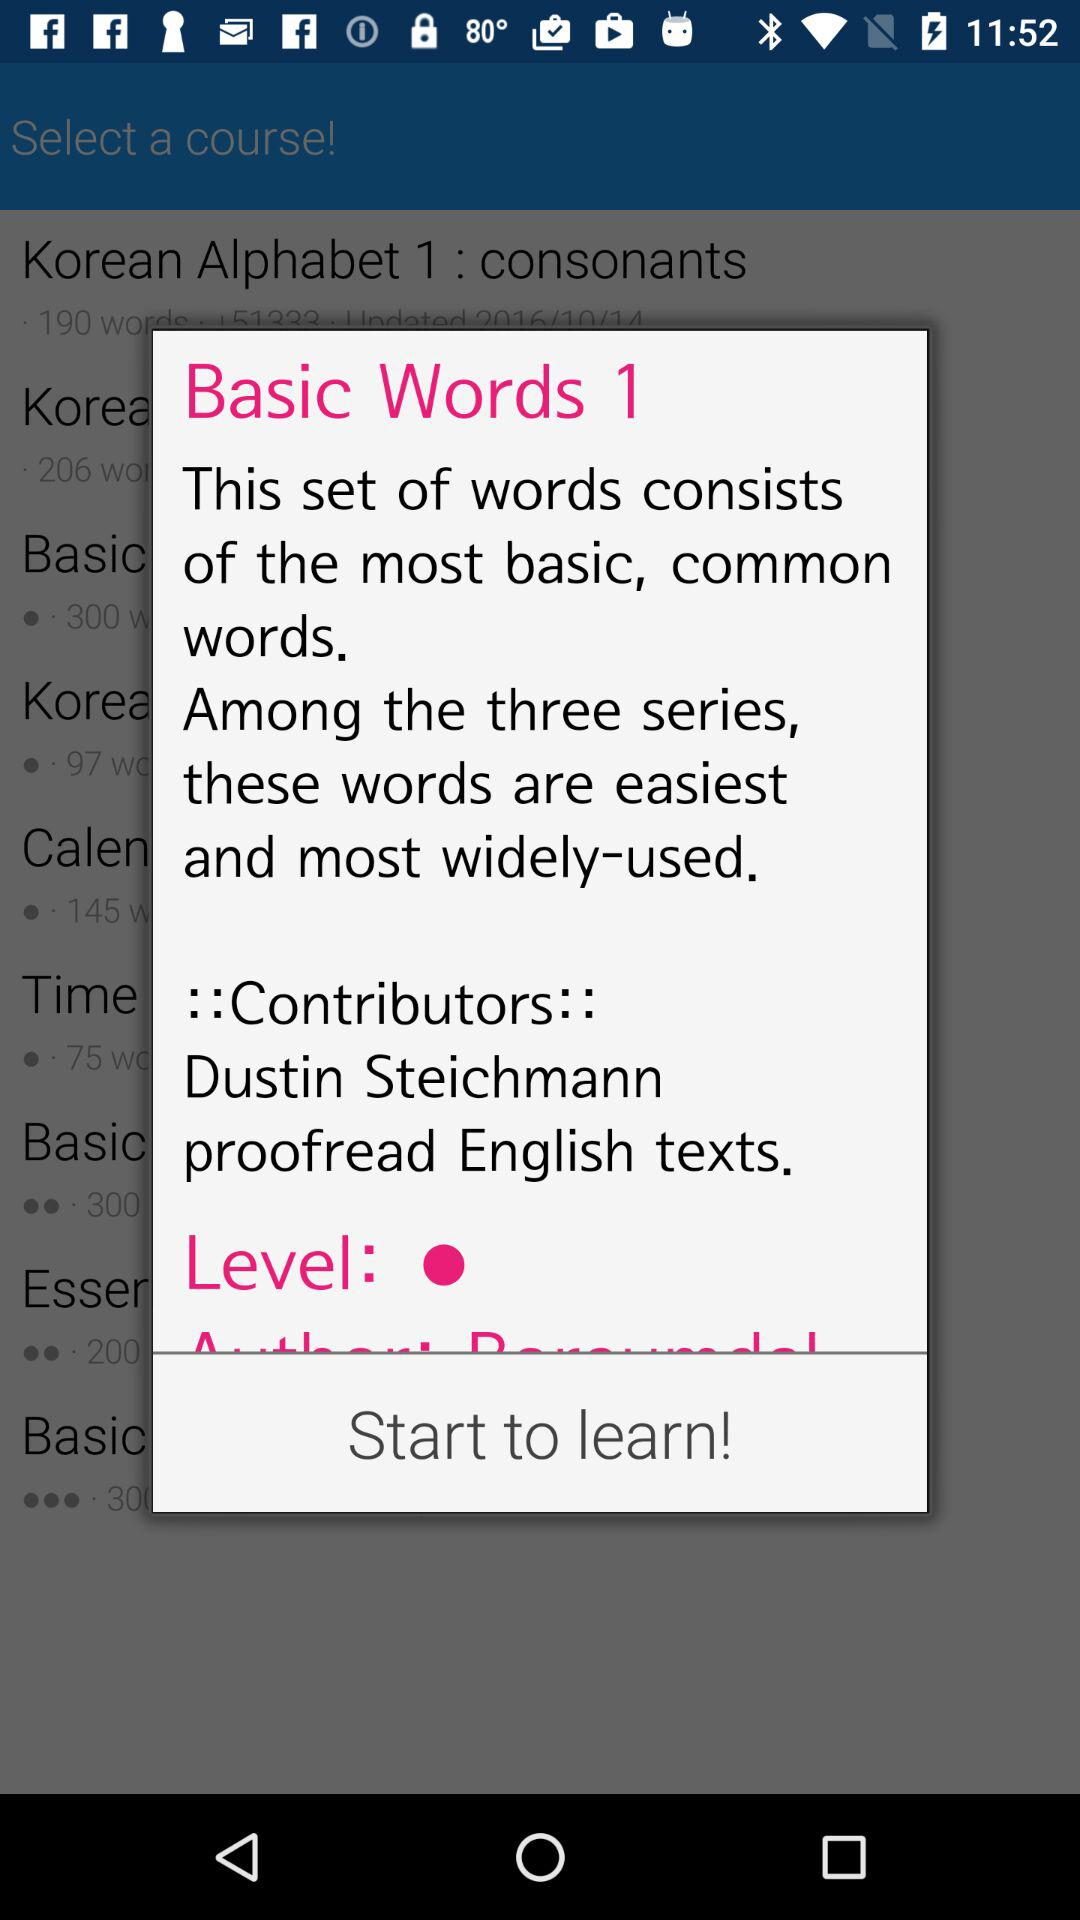How many contributors are there in this course?
Answer the question using a single word or phrase. 1 